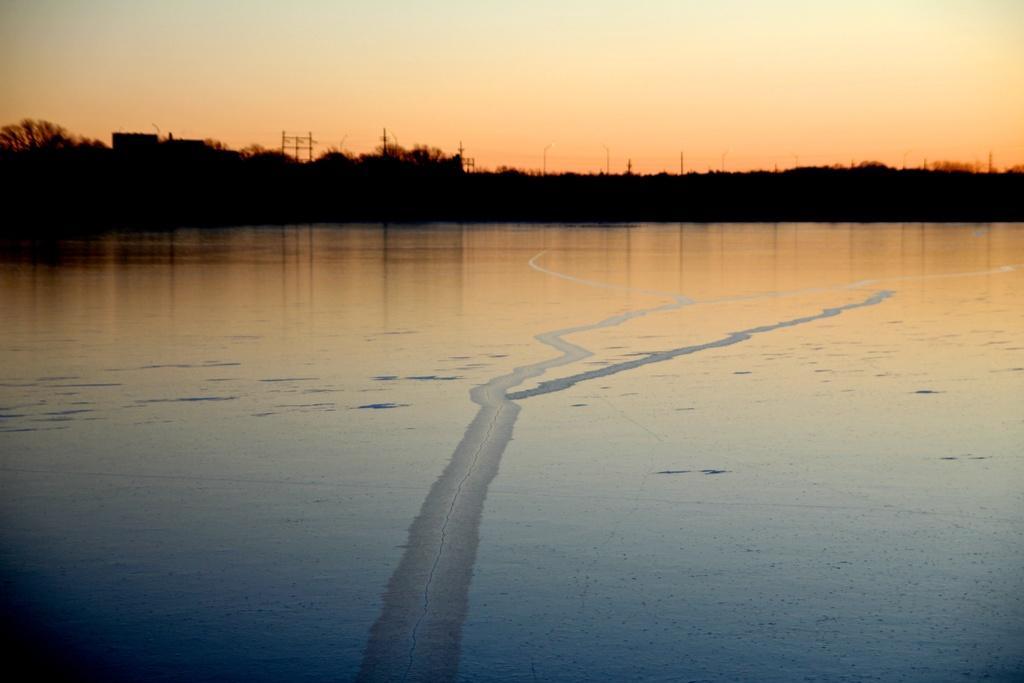How would you summarize this image in a sentence or two? This image consists of water. In the background, there are trees. At the top, there is sky. 